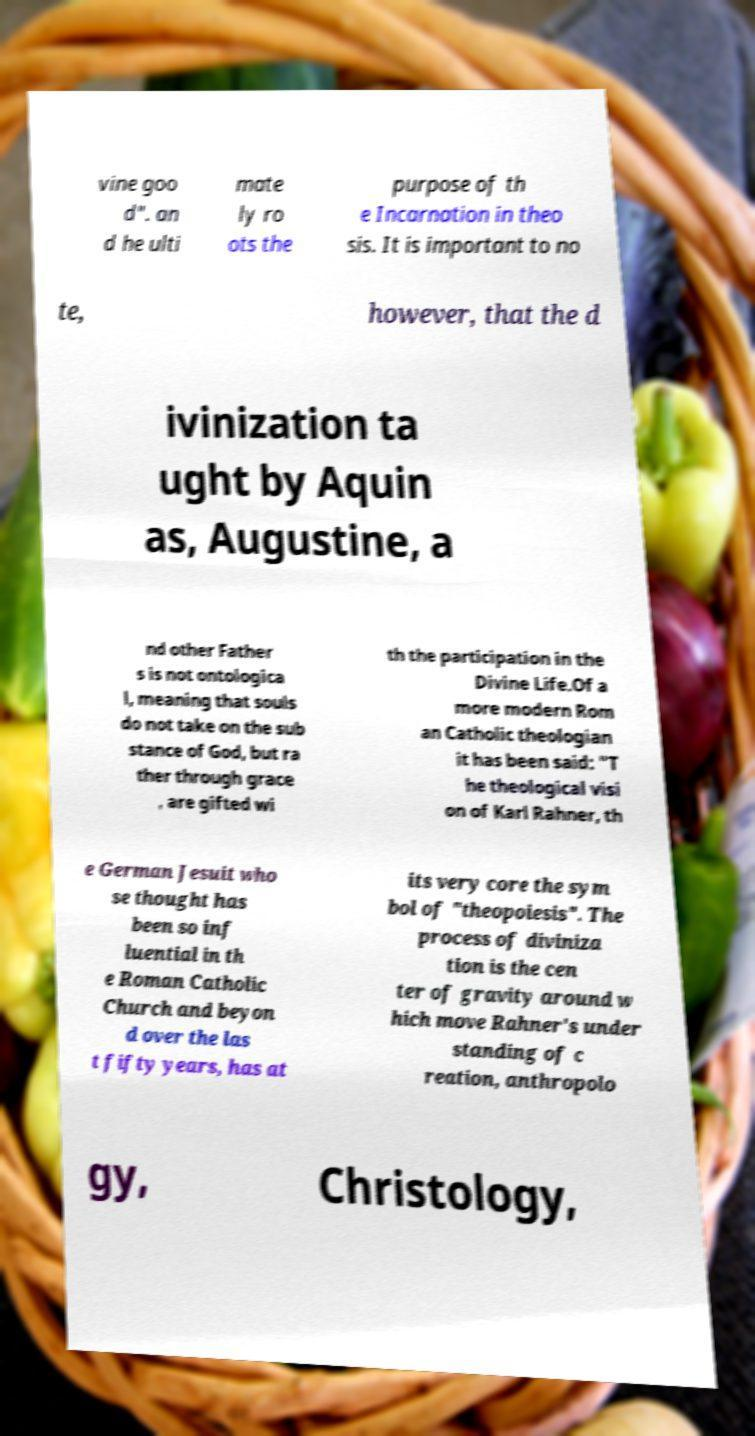What messages or text are displayed in this image? I need them in a readable, typed format. vine goo d". an d he ulti mate ly ro ots the purpose of th e Incarnation in theo sis. It is important to no te, however, that the d ivinization ta ught by Aquin as, Augustine, a nd other Father s is not ontologica l, meaning that souls do not take on the sub stance of God, but ra ther through grace , are gifted wi th the participation in the Divine Life.Of a more modern Rom an Catholic theologian it has been said: "T he theological visi on of Karl Rahner, th e German Jesuit who se thought has been so inf luential in th e Roman Catholic Church and beyon d over the las t fifty years, has at its very core the sym bol of "theopoiesis". The process of diviniza tion is the cen ter of gravity around w hich move Rahner's under standing of c reation, anthropolo gy, Christology, 